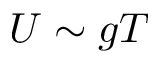<formula> <loc_0><loc_0><loc_500><loc_500>U \sim g T</formula> 